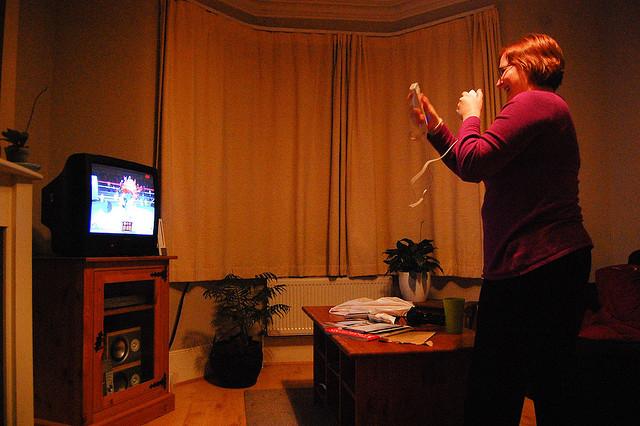What are they doing?
Quick response, please. Wii. What are the women looking at?
Be succinct. Tv. How many people are in the room?
Write a very short answer. 1. Is this a posed picture?
Keep it brief. No. What color is the woman's sweater?
Answer briefly. Red. Where is a potted plant in a white pot?
Keep it brief. By window. What color is her shirt?
Quick response, please. Red. Is this a flat screen?
Give a very brief answer. No. 